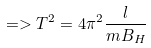Convert formula to latex. <formula><loc_0><loc_0><loc_500><loc_500>= > T ^ { 2 } = 4 \pi ^ { 2 } \frac { l } { m B _ { H } }</formula> 